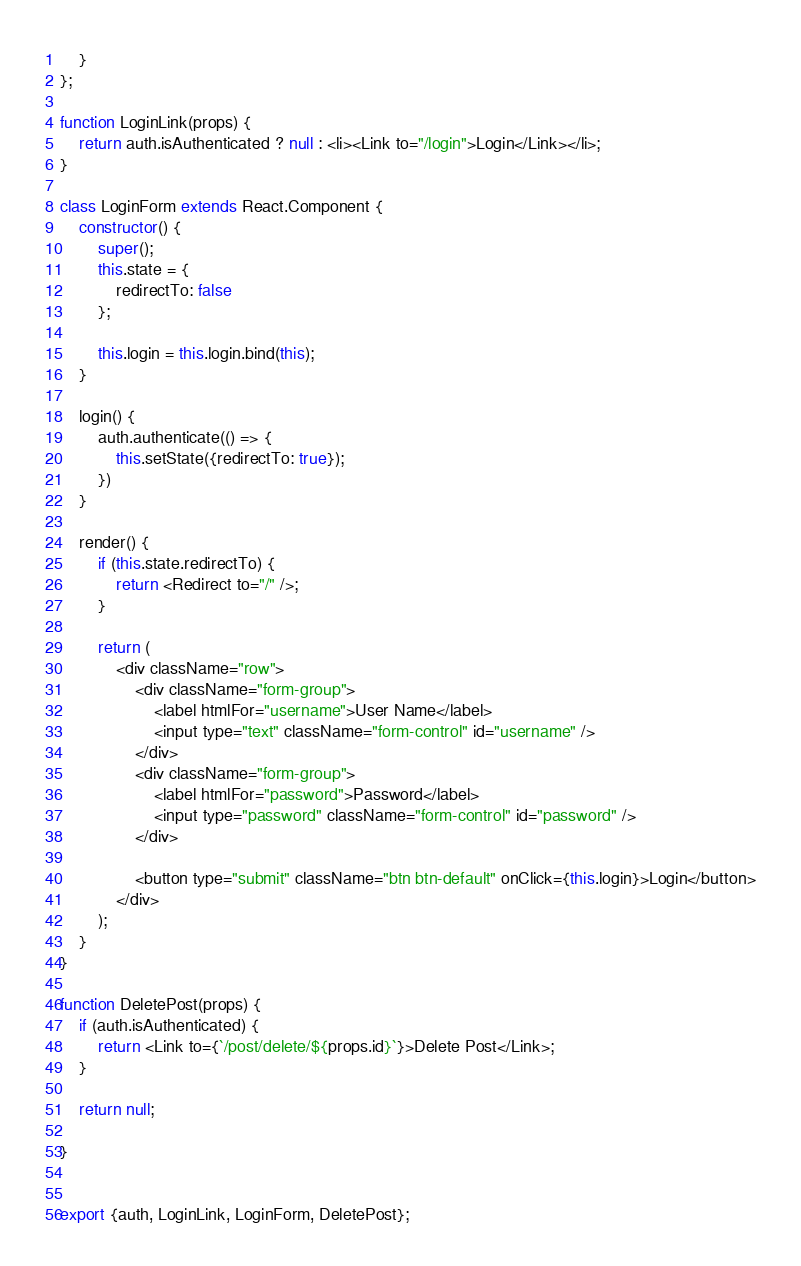Convert code to text. <code><loc_0><loc_0><loc_500><loc_500><_JavaScript_>    }
};

function LoginLink(props) {
    return auth.isAuthenticated ? null : <li><Link to="/login">Login</Link></li>;
}

class LoginForm extends React.Component {
    constructor() {
        super();
        this.state = {
            redirectTo: false
        };

        this.login = this.login.bind(this);
    }

    login() {
        auth.authenticate(() => {
            this.setState({redirectTo: true});
        })
    }

    render() {
        if (this.state.redirectTo) {
            return <Redirect to="/" />;
        }

        return (
            <div className="row">
                <div className="form-group">
                    <label htmlFor="username">User Name</label>
                    <input type="text" className="form-control" id="username" />
                </div>
                <div className="form-group">
                    <label htmlFor="password">Password</label>
                    <input type="password" className="form-control" id="password" />
                </div>

                <button type="submit" className="btn btn-default" onClick={this.login}>Login</button>
            </div>
        );
    }
}

function DeletePost(props) {
    if (auth.isAuthenticated) {
        return <Link to={`/post/delete/${props.id}`}>Delete Post</Link>;
    } 
    
    return null;
    
}


export {auth, LoginLink, LoginForm, DeletePost};</code> 